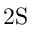<formula> <loc_0><loc_0><loc_500><loc_500>2 S</formula> 